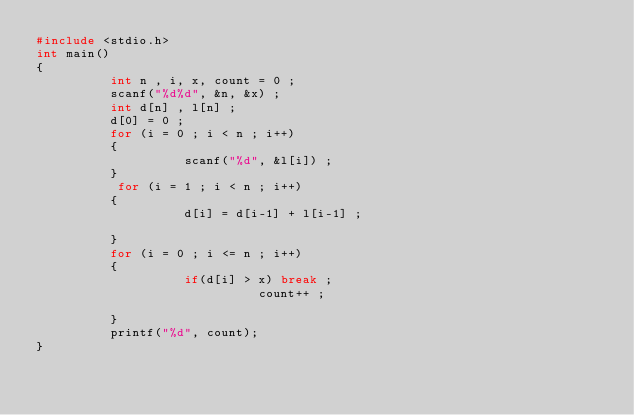<code> <loc_0><loc_0><loc_500><loc_500><_C_>#include <stdio.h>
int main()
{
          int n , i, x, count = 0 ;
          scanf("%d%d", &n, &x) ;
          int d[n] , l[n] ;
          d[0] = 0 ;
          for (i = 0 ; i < n ; i++)
          {
                    scanf("%d", &l[i]) ;
          }
           for (i = 1 ; i < n ; i++)
          {
                    d[i] = d[i-1] + l[i-1] ;

          }
          for (i = 0 ; i <= n ; i++)
          {
                    if(d[i] > x) break ;
                              count++ ;

          }
          printf("%d", count);
}
</code> 